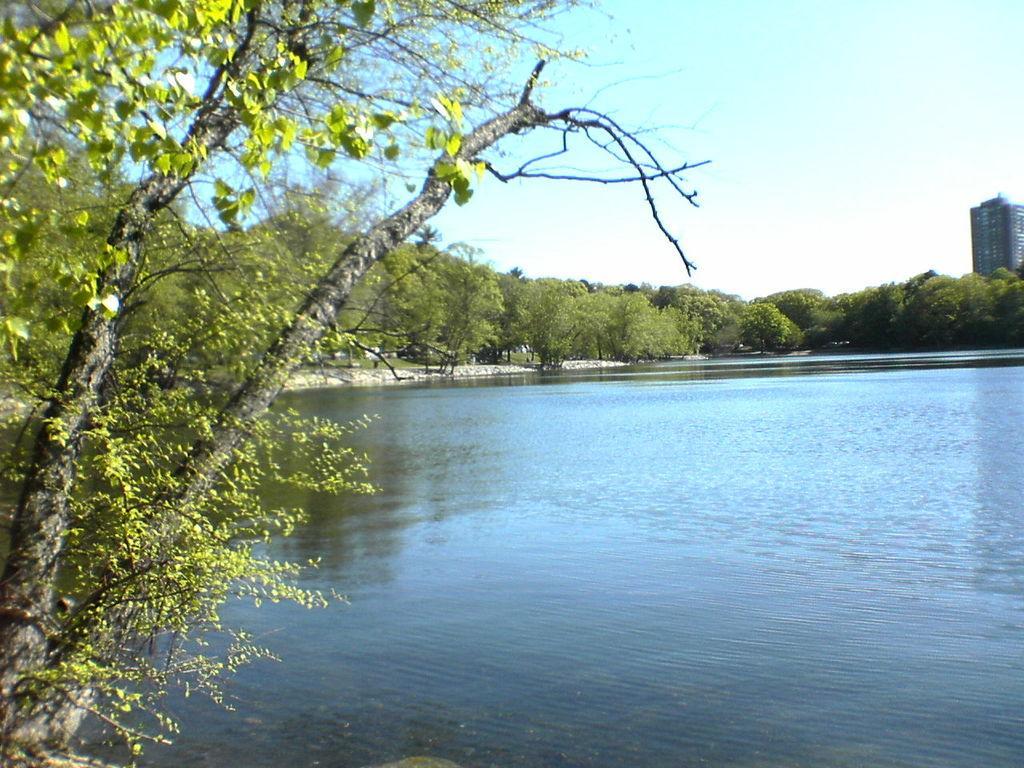How would you summarize this image in a sentence or two? In this picture I can observe a lake in the middle of the picture. In the background I can observe trees and sky. 